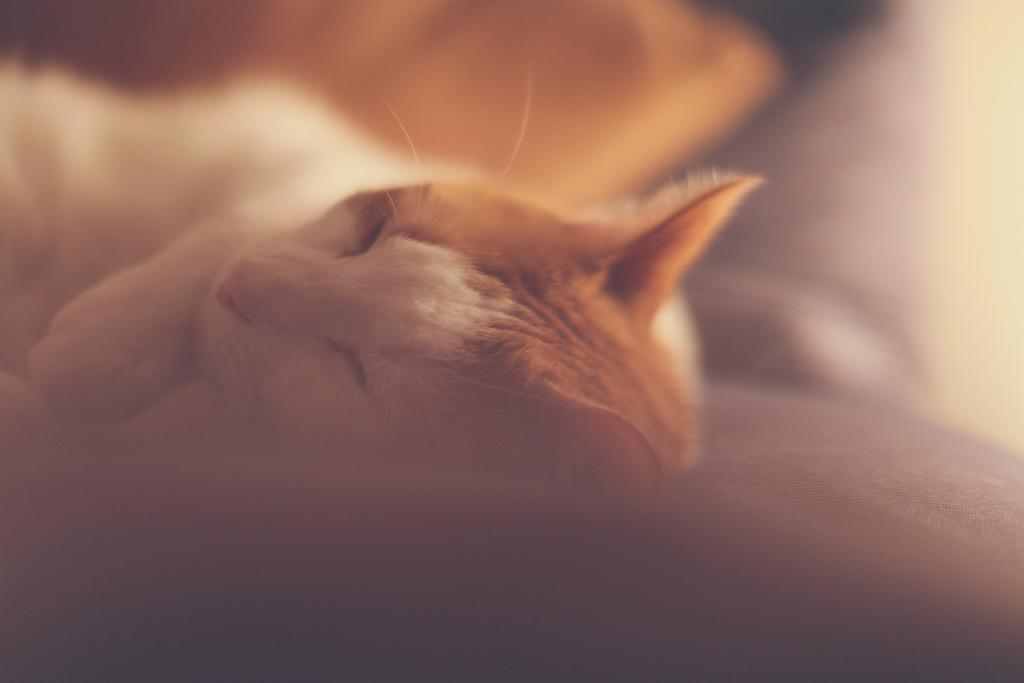What type of animal is in the image? There is a cat in the image. What is the cat doing in the image? The cat is sleeping. How fast is the cat running in the image? The cat is not running in the image; it is sleeping. What type of cable is connected to the cat's face in the image? There is no cable connected to the cat's face in the image; the cat is simply sleeping. 